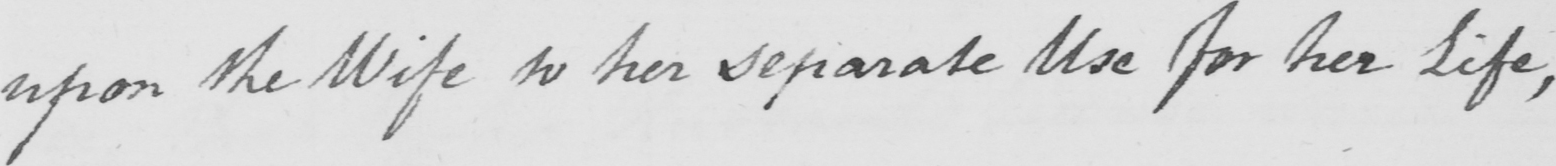What is written in this line of handwriting? upon the Wife to her separate Use for her Life , 